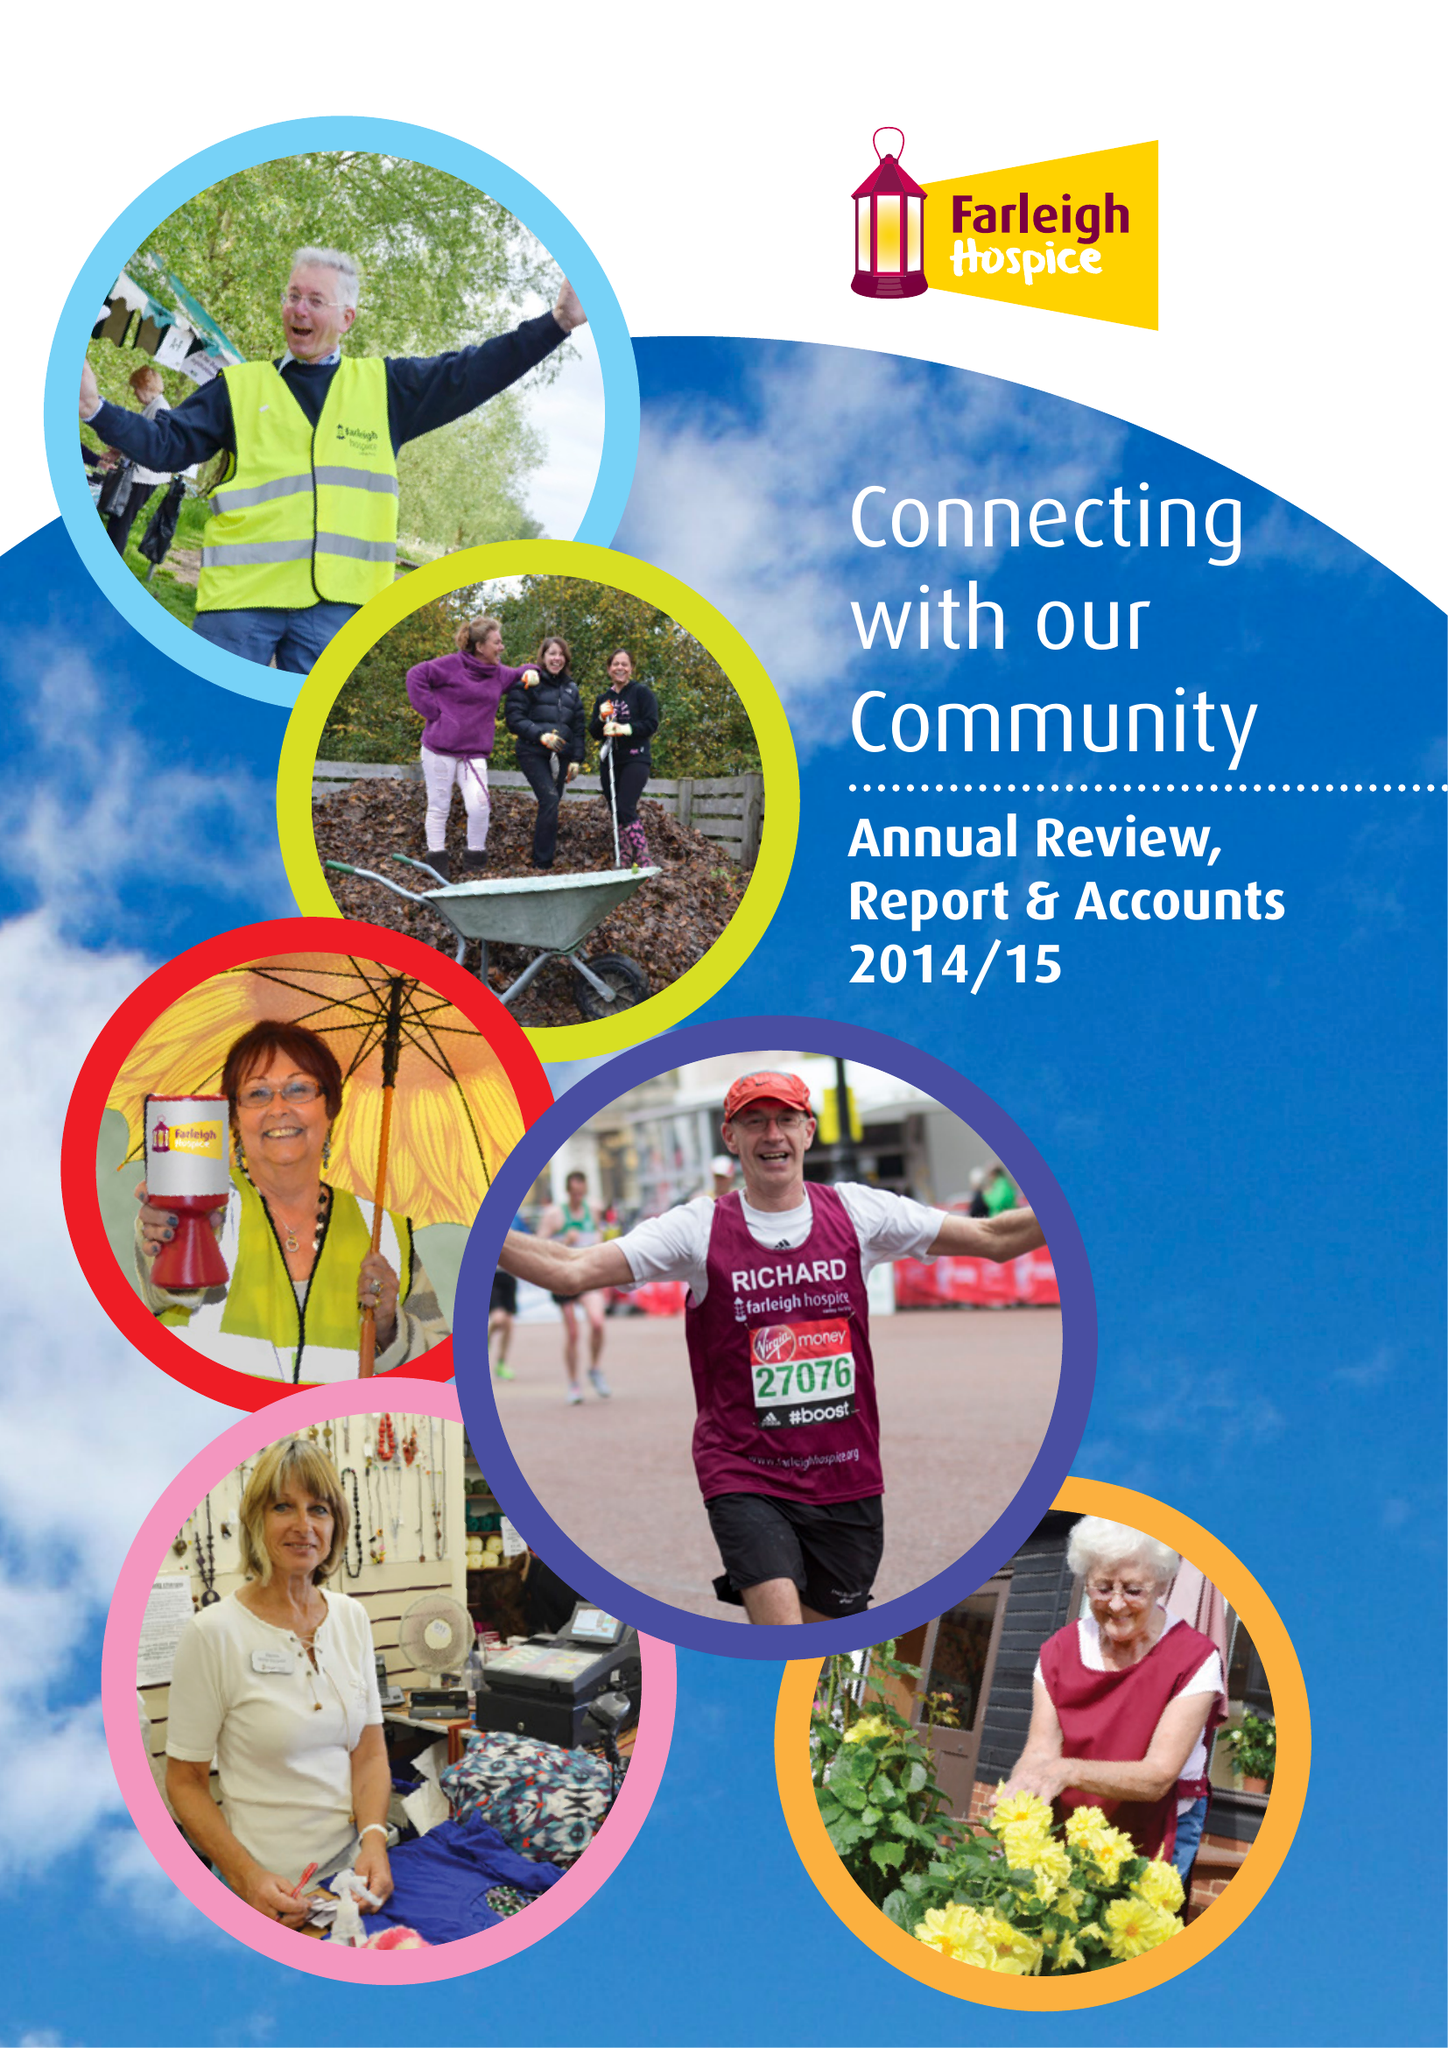What is the value for the address__postcode?
Answer the question using a single word or phrase. CM1 7FH 